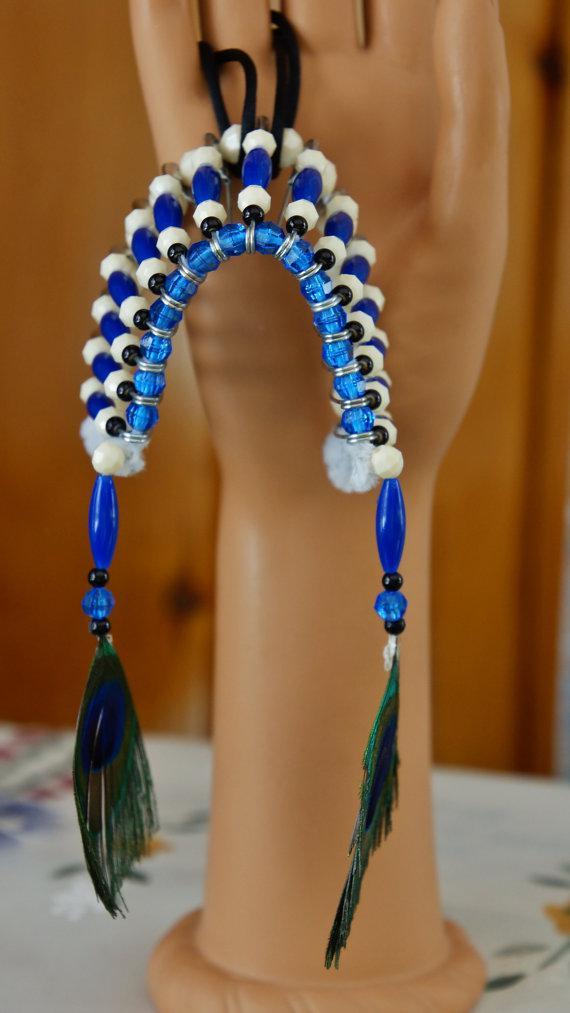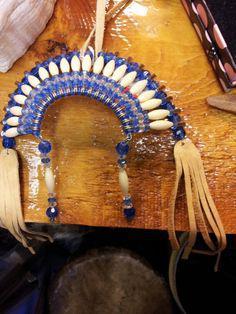The first image is the image on the left, the second image is the image on the right. For the images shown, is this caption "Exactly one of the images contains feathers." true? Answer yes or no. Yes. The first image is the image on the left, the second image is the image on the right. For the images displayed, is the sentence "Left and right images show a decorative item resembling an indian headdress, and at least one of the items is made with blue beads strung on safety pins." factually correct? Answer yes or no. Yes. 